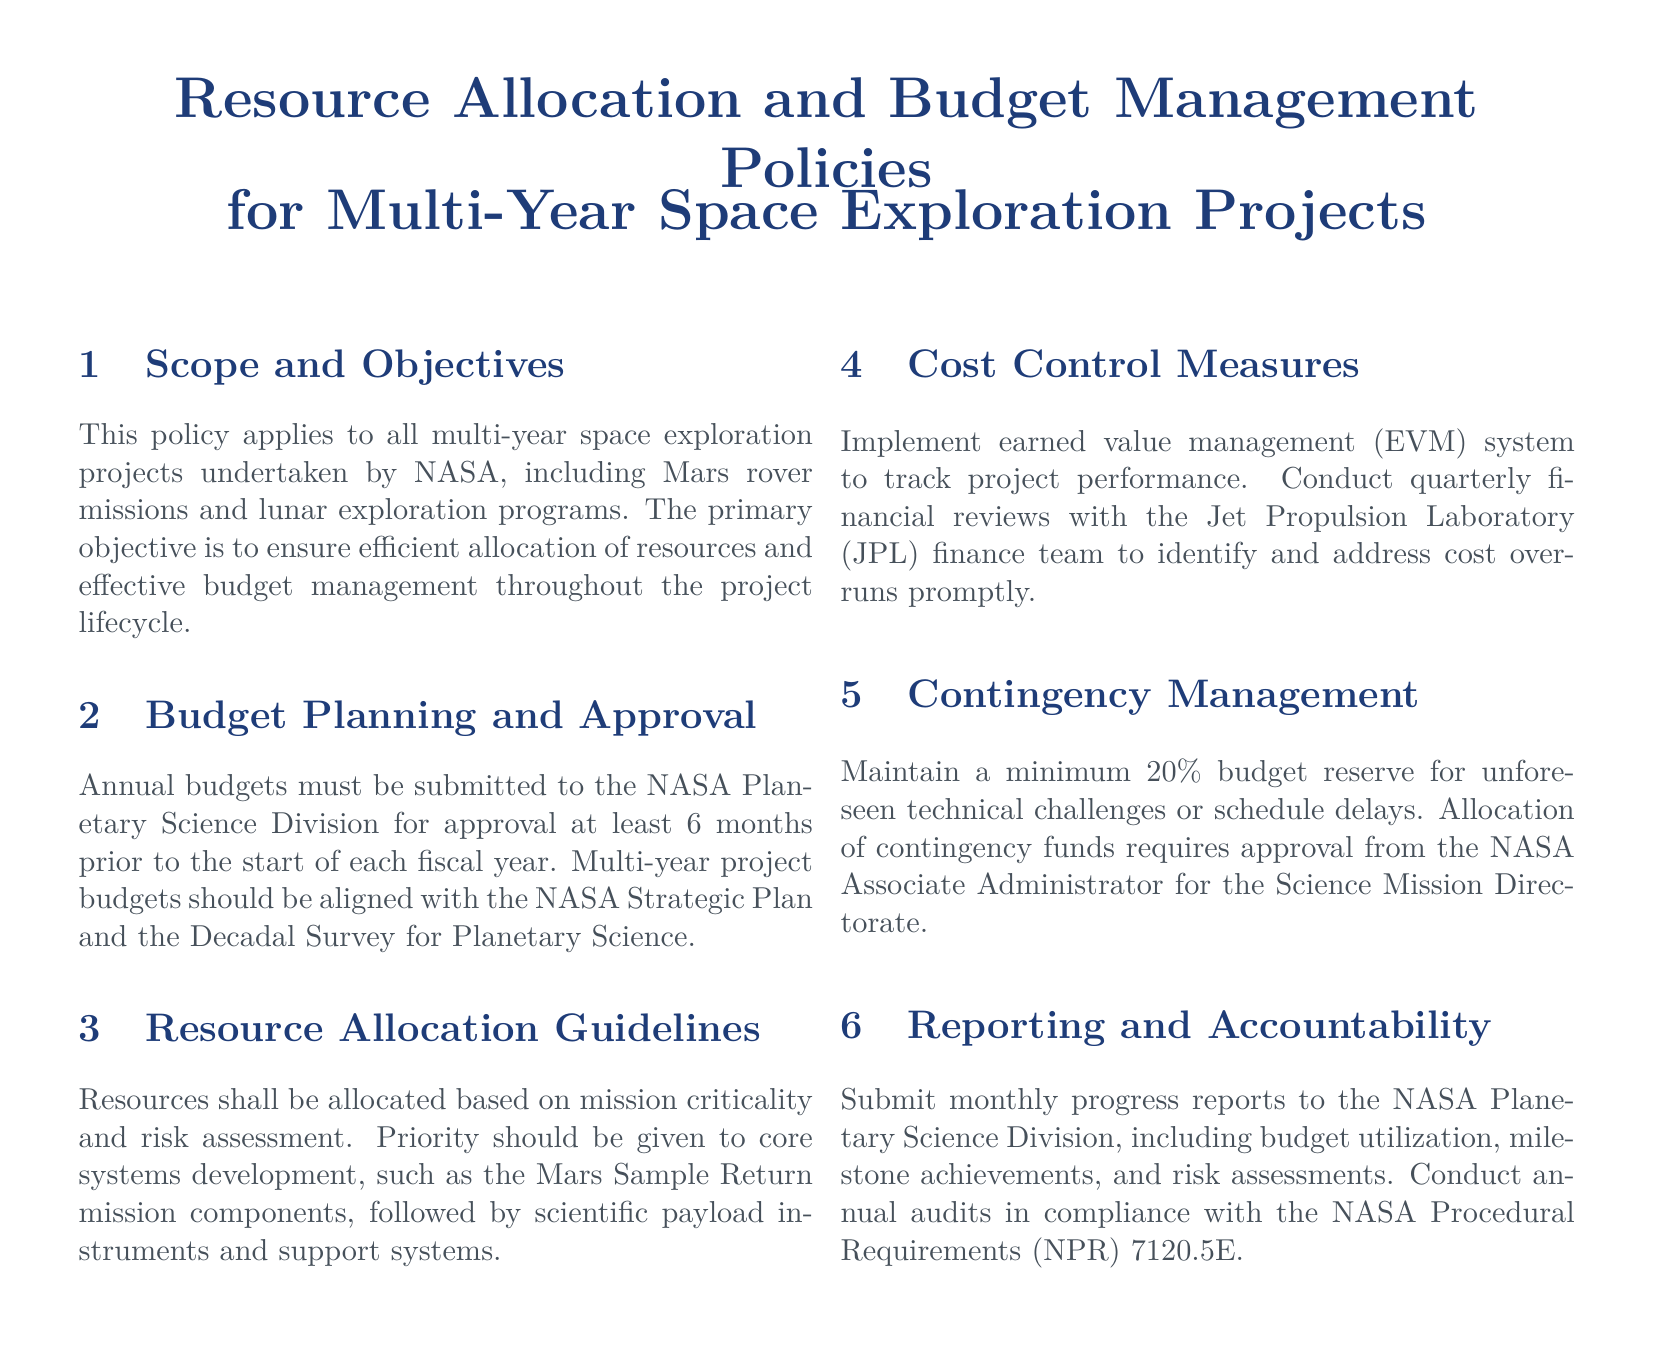What is the primary objective of this policy? The primary objective is to ensure efficient allocation of resources and effective budget management throughout the project lifecycle.
Answer: Efficient allocation of resources and effective budget management How far in advance must annual budgets be submitted for approval? The document states that annual budgets must be submitted at least 6 months prior to the start of each fiscal year.
Answer: 6 months What percentage of the budget should be reserved for unforeseen challenges? The policy specifies that a minimum 20% budget reserve should be maintained for unforeseen technical challenges or schedule delays.
Answer: 20% Who must approve the allocation of contingency funds? The allocation of contingency funds requires approval from the NASA Associate Administrator for the Science Mission Directorate.
Answer: NASA Associate Administrator for the Science Mission Directorate What is the required frequency of financial reviews with JPL's finance team? The document outlines that quarterly financial reviews should be conducted to address cost overruns.
Answer: Quarterly What should be included in the monthly progress reports? Monthly progress reports must include budget utilization, milestone achievements, and risk assessments.
Answer: Budget utilization, milestone achievements, and risk assessments Which system is implemented for tracking project performance? The policy states that an earned value management (EVM) system is used to track project performance.
Answer: Earned value management (EVM) What is the document type? This document outlines policies related to resource allocation and budget management for specific projects.
Answer: Policy document 